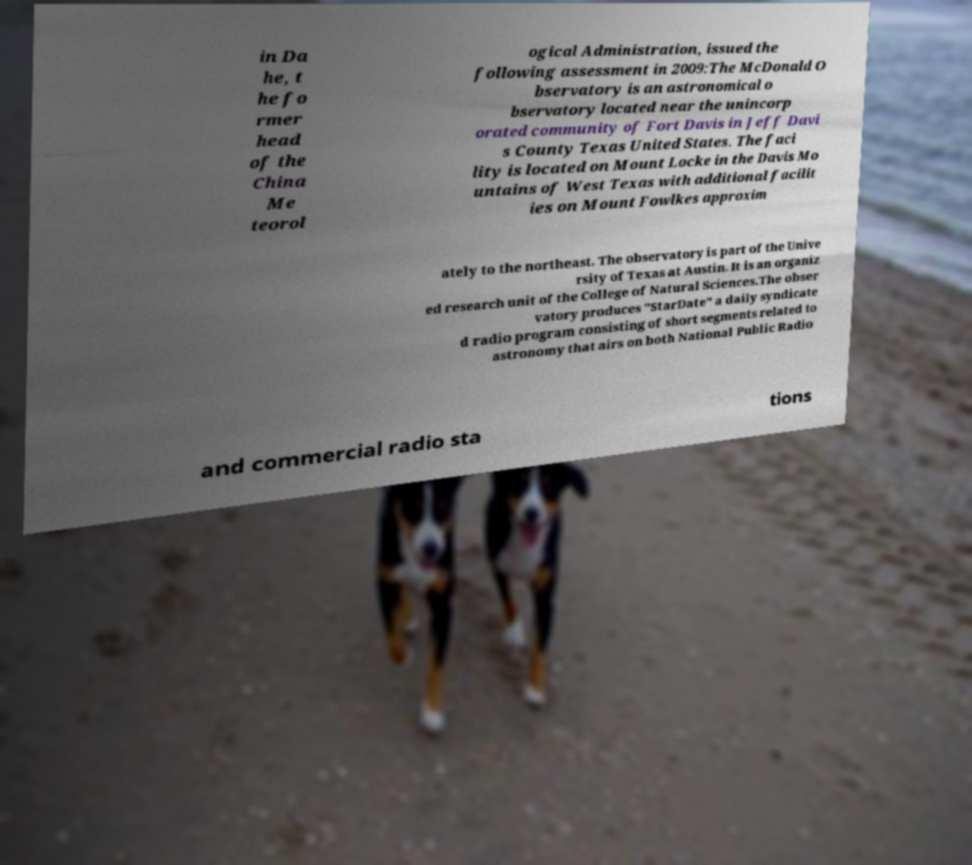Could you extract and type out the text from this image? in Da he, t he fo rmer head of the China Me teorol ogical Administration, issued the following assessment in 2009:The McDonald O bservatory is an astronomical o bservatory located near the unincorp orated community of Fort Davis in Jeff Davi s County Texas United States. The faci lity is located on Mount Locke in the Davis Mo untains of West Texas with additional facilit ies on Mount Fowlkes approxim ately to the northeast. The observatory is part of the Unive rsity of Texas at Austin. It is an organiz ed research unit of the College of Natural Sciences.The obser vatory produces "StarDate" a daily syndicate d radio program consisting of short segments related to astronomy that airs on both National Public Radio and commercial radio sta tions 